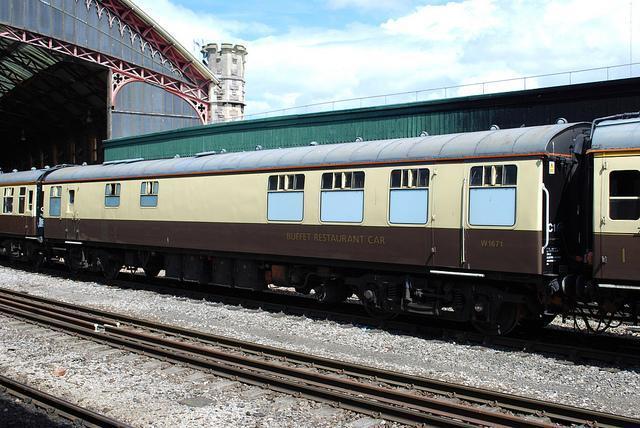How many trains are in the picture?
Give a very brief answer. 1. 